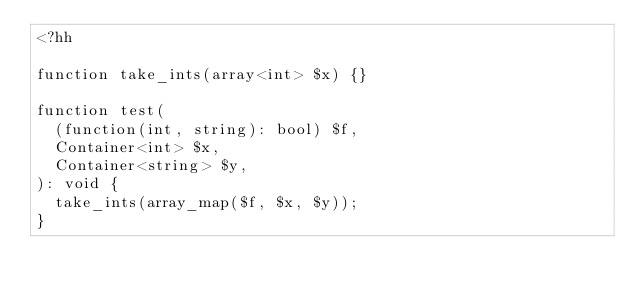<code> <loc_0><loc_0><loc_500><loc_500><_PHP_><?hh

function take_ints(array<int> $x) {}

function test(
  (function(int, string): bool) $f,
  Container<int> $x,
  Container<string> $y,
): void {
  take_ints(array_map($f, $x, $y));
}
</code> 